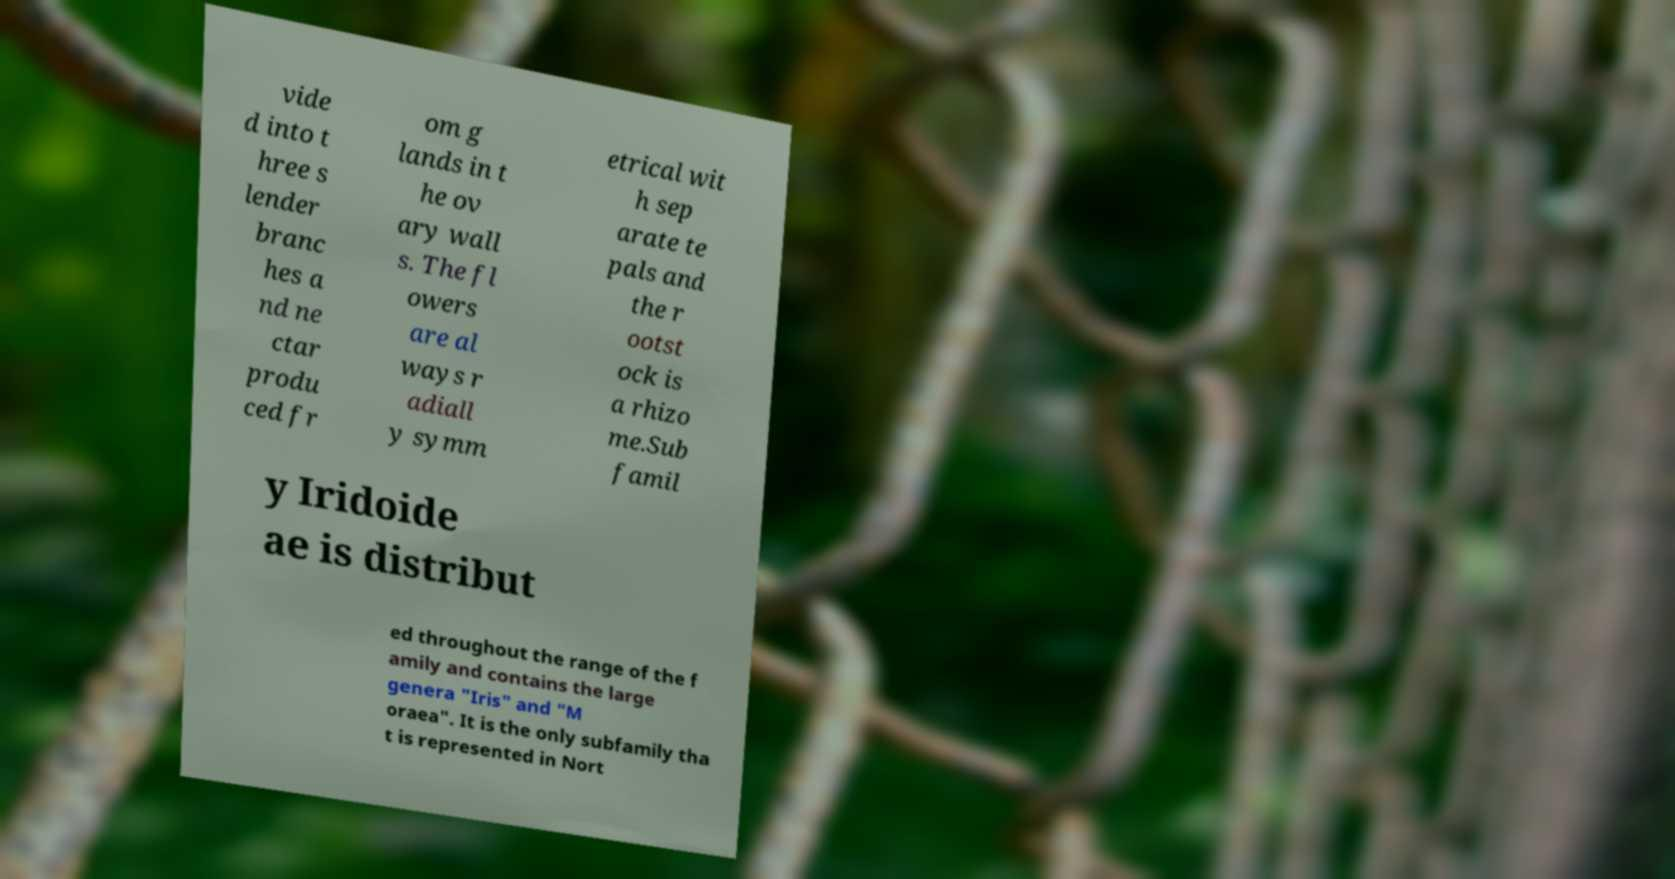Can you read and provide the text displayed in the image?This photo seems to have some interesting text. Can you extract and type it out for me? vide d into t hree s lender branc hes a nd ne ctar produ ced fr om g lands in t he ov ary wall s. The fl owers are al ways r adiall y symm etrical wit h sep arate te pals and the r ootst ock is a rhizo me.Sub famil y Iridoide ae is distribut ed throughout the range of the f amily and contains the large genera "Iris" and "M oraea". It is the only subfamily tha t is represented in Nort 